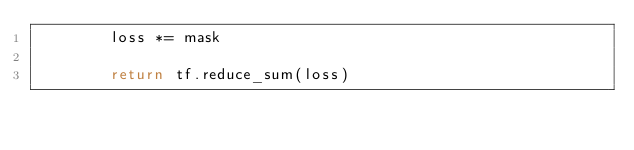<code> <loc_0><loc_0><loc_500><loc_500><_Python_>        loss *= mask

        return tf.reduce_sum(loss)
</code> 